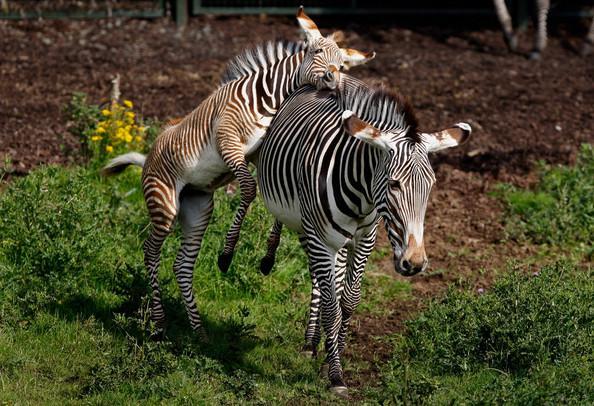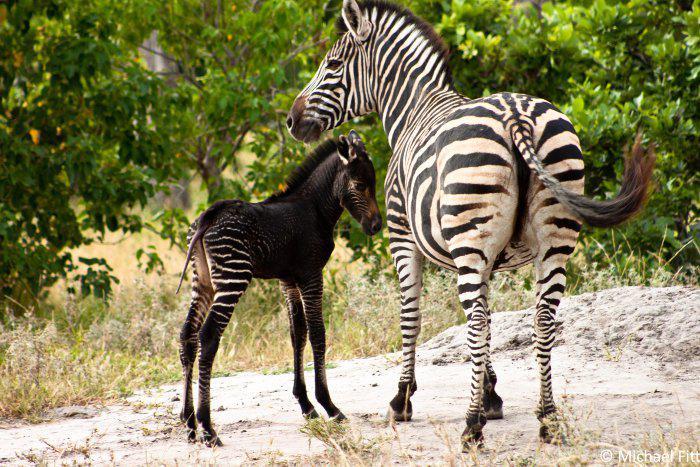The first image is the image on the left, the second image is the image on the right. Analyze the images presented: Is the assertion "One image has a zebra laying on the ground." valid? Answer yes or no. No. The first image is the image on the left, the second image is the image on the right. Evaluate the accuracy of this statement regarding the images: "The left image shows a zebra colt standing alongside and in front of an adult zebra that faces the same direction, and the right image contains only a zebra colt, which faces forward and is not standing upright.". Is it true? Answer yes or no. No. 